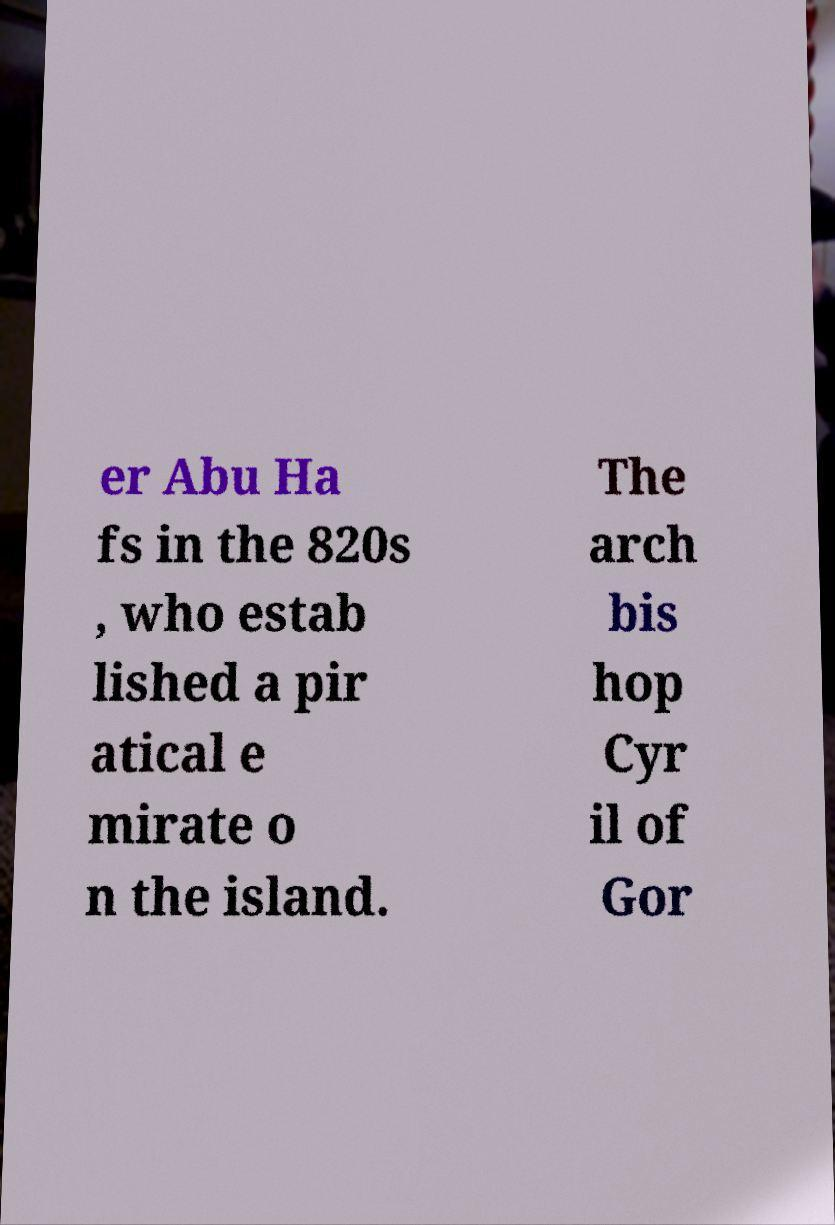What messages or text are displayed in this image? I need them in a readable, typed format. er Abu Ha fs in the 820s , who estab lished a pir atical e mirate o n the island. The arch bis hop Cyr il of Gor 